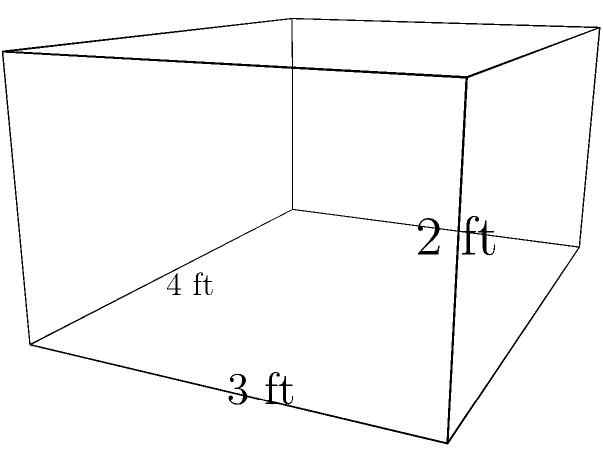As an insurance claim expert, you're organizing a new filing cabinet for your social media content creation workspace. The cabinet is shaped like a rectangular prism with dimensions 4 ft x 3 ft x 2 ft. To protect it from potential water damage, you want to cover the entire surface with a special waterproof material. How many square feet of this material do you need to cover the entire surface area of the filing cabinet? Let's approach this step-by-step:

1) The surface area of a rectangular prism is the sum of the areas of all six faces.

2) We have three pairs of identical faces:
   - Front and back (length x height)
   - Top and bottom (length x width)
   - Left and right sides (width x height)

3) Let's calculate the area of each pair:
   - Front/back: $4 \text{ ft} \times 2 \text{ ft} = 8 \text{ sq ft}$ (each)
   - Top/bottom: $4 \text{ ft} \times 3 \text{ ft} = 12 \text{ sq ft}$ (each)
   - Left/right: $3 \text{ ft} \times 2 \text{ ft} = 6 \text{ sq ft}$ (each)

4) Now, let's sum up all the areas:
   $$(2 \times 8) + (2 \times 12) + (2 \times 6) = 16 + 24 + 12 = 52 \text{ sq ft}$$

5) Therefore, the total surface area is 52 square feet.
Answer: 52 sq ft 